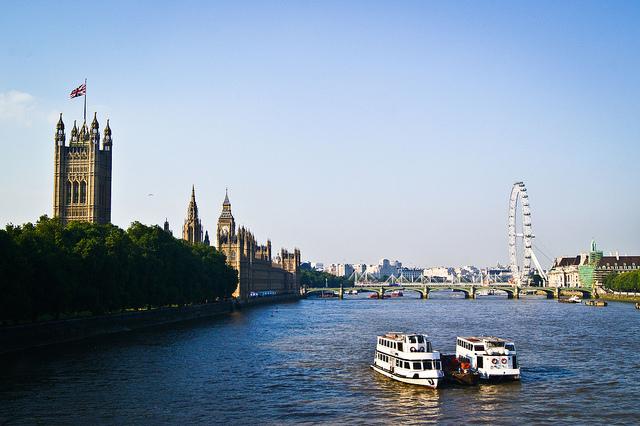Are there people on this ferry boat?
Write a very short answer. Yes. What time of day is it?
Write a very short answer. Noon. What type of vessel is in view?
Short answer required. Boat. How many flags?
Quick response, please. 1. Is a bridge visible?
Write a very short answer. Yes. What city is this in?
Write a very short answer. London. 